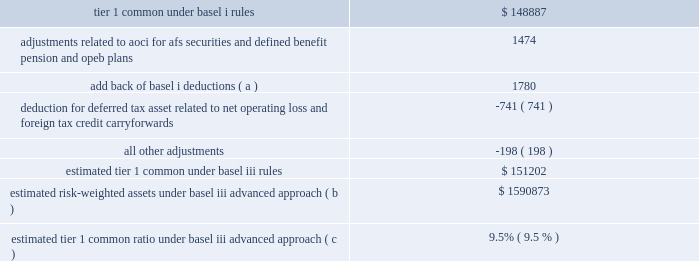Management 2019s discussion and analysis 164 jpmorgan chase & co./2013 annual report firm ) is required to hold more than the additional 2.5% ( 2.5 % ) of tier 1 common .
In addition , basel iii establishes a 6.5% ( 6.5 % ) tier i common equity standard for the definition of 201cwell capitalized 201d under the prompt corrective action ( 201cpca 201d ) requirements of the fdic improvement act ( 201cfdicia 201d ) .
The tier i common equity standard is effective from the first quarter of 2015 .
The following chart presents the basel iii minimum risk-based capital ratios during the transitional periods and on a fully phased-in basis .
The chart also includes management 2019s target for the firm 2019s tier 1 common ratio .
It is the firm 2019s current expectation that its basel iii tier 1 common ratio will exceed the regulatory minimums , both during the transition period and upon full implementation in 2019 and thereafter .
The firm estimates that its tier 1 common ratio under the basel iii advanced approach on a fully phased-in basis would be 9.5% ( 9.5 % ) as of december 31 , 2013 , achieving management 2019s previously stated objectives .
The tier 1 common ratio as calculated under the basel iii standardized approach is estimated at 9.4% ( 9.4 % ) as of december 31 , 2013 .
The tier 1 common ratio under both basel i and basel iii are non-gaap financial measures .
However , such measures are used by bank regulators , investors and analysts to assess the firm 2019s capital position and to compare the firm 2019s capital to that of other financial services companies .
The table presents a comparison of the firm 2019s tier 1 common under basel i rules to its estimated tier 1 common under the advanced approach of the basel iii rules , along with the firm 2019s estimated risk-weighted assets .
Key differences in the calculation of rwa between basel i and basel iii advanced approach include : ( 1 ) basel iii credit risk rwa is based on risk-sensitive approaches which largely rely on the use of internal credit models and parameters , whereas basel i rwa is based on fixed supervisory risk- weightings which vary only by counterparty type and asset class ; and ( 2 ) basel iii includes rwa for operational risk , whereas basel i does not .
Operational risk capital takes into consideration operational losses in the quarter following the period in which those losses were realized , and the calculation generally incorporates such losses irrespective of whether the issues or business activity giving rise to the losses have been remediated or reduced .
The firm 2019s operational risk capital model continues to be refined in conjunction with the firm 2019s basel iii advanced approach parallel run .
As a result of model enhancements in 2013 , as well as taking into consideration the legal expenses incurred by the firm in 2013 , the firm 2019s operational risk capital increased substantially in 2013 over 2012 .
Tier 1 common under basel iii includes additional adjustments and deductions not included in basel i tier 1 common , such as the inclusion of accumulated other comprehensive income ( 201caoci 201d ) related to afs securities and defined benefit pension and other postretirement employee benefit ( 201copeb 201d ) plans .
December 31 , 2013 ( in millions , except ratios ) .
Estimated risk-weighted assets under basel iii advanced approach ( b ) $ 1590873 estimated tier 1 common ratio under basel iii advanced approach ( c ) 9.5% ( 9.5 % ) ( a ) certain exposures , which are deducted from capital under basel i , are risked-weighted under basel iii. .
For basel adjustments , what would tier 1 capital have declined absent adjustments related to aoci and basel adjustments?\\n? 
Computations: (1474 + 1780)
Answer: 3254.0. Management 2019s discussion and analysis 164 jpmorgan chase & co./2013 annual report firm ) is required to hold more than the additional 2.5% ( 2.5 % ) of tier 1 common .
In addition , basel iii establishes a 6.5% ( 6.5 % ) tier i common equity standard for the definition of 201cwell capitalized 201d under the prompt corrective action ( 201cpca 201d ) requirements of the fdic improvement act ( 201cfdicia 201d ) .
The tier i common equity standard is effective from the first quarter of 2015 .
The following chart presents the basel iii minimum risk-based capital ratios during the transitional periods and on a fully phased-in basis .
The chart also includes management 2019s target for the firm 2019s tier 1 common ratio .
It is the firm 2019s current expectation that its basel iii tier 1 common ratio will exceed the regulatory minimums , both during the transition period and upon full implementation in 2019 and thereafter .
The firm estimates that its tier 1 common ratio under the basel iii advanced approach on a fully phased-in basis would be 9.5% ( 9.5 % ) as of december 31 , 2013 , achieving management 2019s previously stated objectives .
The tier 1 common ratio as calculated under the basel iii standardized approach is estimated at 9.4% ( 9.4 % ) as of december 31 , 2013 .
The tier 1 common ratio under both basel i and basel iii are non-gaap financial measures .
However , such measures are used by bank regulators , investors and analysts to assess the firm 2019s capital position and to compare the firm 2019s capital to that of other financial services companies .
The table presents a comparison of the firm 2019s tier 1 common under basel i rules to its estimated tier 1 common under the advanced approach of the basel iii rules , along with the firm 2019s estimated risk-weighted assets .
Key differences in the calculation of rwa between basel i and basel iii advanced approach include : ( 1 ) basel iii credit risk rwa is based on risk-sensitive approaches which largely rely on the use of internal credit models and parameters , whereas basel i rwa is based on fixed supervisory risk- weightings which vary only by counterparty type and asset class ; and ( 2 ) basel iii includes rwa for operational risk , whereas basel i does not .
Operational risk capital takes into consideration operational losses in the quarter following the period in which those losses were realized , and the calculation generally incorporates such losses irrespective of whether the issues or business activity giving rise to the losses have been remediated or reduced .
The firm 2019s operational risk capital model continues to be refined in conjunction with the firm 2019s basel iii advanced approach parallel run .
As a result of model enhancements in 2013 , as well as taking into consideration the legal expenses incurred by the firm in 2013 , the firm 2019s operational risk capital increased substantially in 2013 over 2012 .
Tier 1 common under basel iii includes additional adjustments and deductions not included in basel i tier 1 common , such as the inclusion of accumulated other comprehensive income ( 201caoci 201d ) related to afs securities and defined benefit pension and other postretirement employee benefit ( 201copeb 201d ) plans .
December 31 , 2013 ( in millions , except ratios ) .
Estimated risk-weighted assets under basel iii advanced approach ( b ) $ 1590873 estimated tier 1 common ratio under basel iii advanced approach ( c ) 9.5% ( 9.5 % ) ( a ) certain exposures , which are deducted from capital under basel i , are risked-weighted under basel iii. .
What would the estimated minimum amount of tier 1 common equity be under the minimum basel 6.5% ( 6.5 % ) standard ? ( billions )? 
Rationale: estimate total capital by dividing by the actual 9.4%
Computations: ((151202 / 9.4%) * 6.5%)
Answer: 104554.57447. Management 2019s discussion and analysis 164 jpmorgan chase & co./2013 annual report firm ) is required to hold more than the additional 2.5% ( 2.5 % ) of tier 1 common .
In addition , basel iii establishes a 6.5% ( 6.5 % ) tier i common equity standard for the definition of 201cwell capitalized 201d under the prompt corrective action ( 201cpca 201d ) requirements of the fdic improvement act ( 201cfdicia 201d ) .
The tier i common equity standard is effective from the first quarter of 2015 .
The following chart presents the basel iii minimum risk-based capital ratios during the transitional periods and on a fully phased-in basis .
The chart also includes management 2019s target for the firm 2019s tier 1 common ratio .
It is the firm 2019s current expectation that its basel iii tier 1 common ratio will exceed the regulatory minimums , both during the transition period and upon full implementation in 2019 and thereafter .
The firm estimates that its tier 1 common ratio under the basel iii advanced approach on a fully phased-in basis would be 9.5% ( 9.5 % ) as of december 31 , 2013 , achieving management 2019s previously stated objectives .
The tier 1 common ratio as calculated under the basel iii standardized approach is estimated at 9.4% ( 9.4 % ) as of december 31 , 2013 .
The tier 1 common ratio under both basel i and basel iii are non-gaap financial measures .
However , such measures are used by bank regulators , investors and analysts to assess the firm 2019s capital position and to compare the firm 2019s capital to that of other financial services companies .
The table presents a comparison of the firm 2019s tier 1 common under basel i rules to its estimated tier 1 common under the advanced approach of the basel iii rules , along with the firm 2019s estimated risk-weighted assets .
Key differences in the calculation of rwa between basel i and basel iii advanced approach include : ( 1 ) basel iii credit risk rwa is based on risk-sensitive approaches which largely rely on the use of internal credit models and parameters , whereas basel i rwa is based on fixed supervisory risk- weightings which vary only by counterparty type and asset class ; and ( 2 ) basel iii includes rwa for operational risk , whereas basel i does not .
Operational risk capital takes into consideration operational losses in the quarter following the period in which those losses were realized , and the calculation generally incorporates such losses irrespective of whether the issues or business activity giving rise to the losses have been remediated or reduced .
The firm 2019s operational risk capital model continues to be refined in conjunction with the firm 2019s basel iii advanced approach parallel run .
As a result of model enhancements in 2013 , as well as taking into consideration the legal expenses incurred by the firm in 2013 , the firm 2019s operational risk capital increased substantially in 2013 over 2012 .
Tier 1 common under basel iii includes additional adjustments and deductions not included in basel i tier 1 common , such as the inclusion of accumulated other comprehensive income ( 201caoci 201d ) related to afs securities and defined benefit pension and other postretirement employee benefit ( 201copeb 201d ) plans .
December 31 , 2013 ( in millions , except ratios ) .
Estimated risk-weighted assets under basel iii advanced approach ( b ) $ 1590873 estimated tier 1 common ratio under basel iii advanced approach ( c ) 9.5% ( 9.5 % ) ( a ) certain exposures , which are deducted from capital under basel i , are risked-weighted under basel iii. .
In december 2013 what was the ratio of the estimated risk-weighted assets under basel iii advanced approach to the estimated tier 1 common under basel iii rules? 
Computations: (1590873 / 151202)
Answer: 10.52151. 